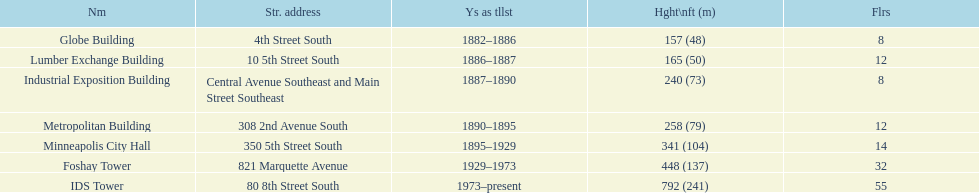Which is taller, the metropolitan building or the lumber exchange building? Metropolitan Building. 